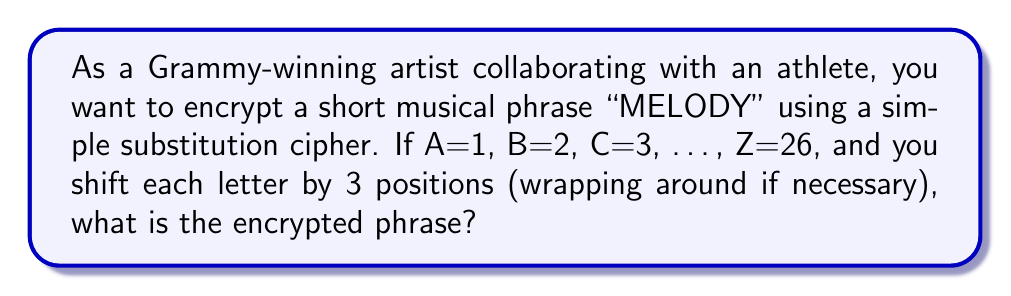Provide a solution to this math problem. To encrypt the phrase "MELODY" using the given substitution cipher, we follow these steps:

1. Assign numbers to each letter:
   M = 13, E = 5, L = 12, O = 15, D = 4, Y = 25

2. Shift each number by 3 positions:
   M (13) → 16
   E (5) → 8
   L (12) → 15
   O (15) → 18
   D (4) → 7
   Y (25) → 2

3. Convert the shifted numbers back to letters:
   16 = P
   8 = H
   15 = O
   18 = R
   7 = G
   2 = B

Therefore, the encrypted phrase is "PHOGRB".

This can be represented mathematically as:

For each letter $x$ in the original phrase, the encrypted letter $y$ is given by:

$$ y = ((x - 1 + 3) \bmod 26) + 1 $$

Where $\bmod$ represents the modulo operation to ensure wrapping around the alphabet.
Answer: PHOGRB 